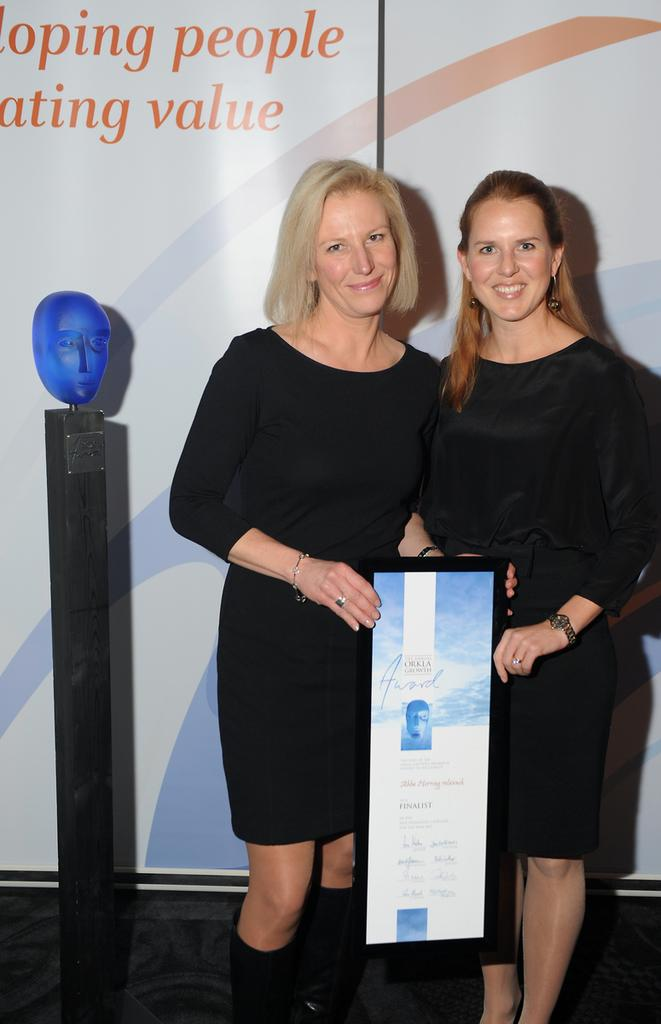How many people are in the image? There are two women in the image. What are the women holding in the image? The women are holding a board. What else can be seen in the image besides the women and the board? There is a banner visible in the image. What information is provided on the banner? Words are written on the banner. Can you see any fangs on the women in the image? There are no fangs visible on the women in the image. Are the women using the board to skate in the image? There is no indication that the women are using the board to skate in the image. 